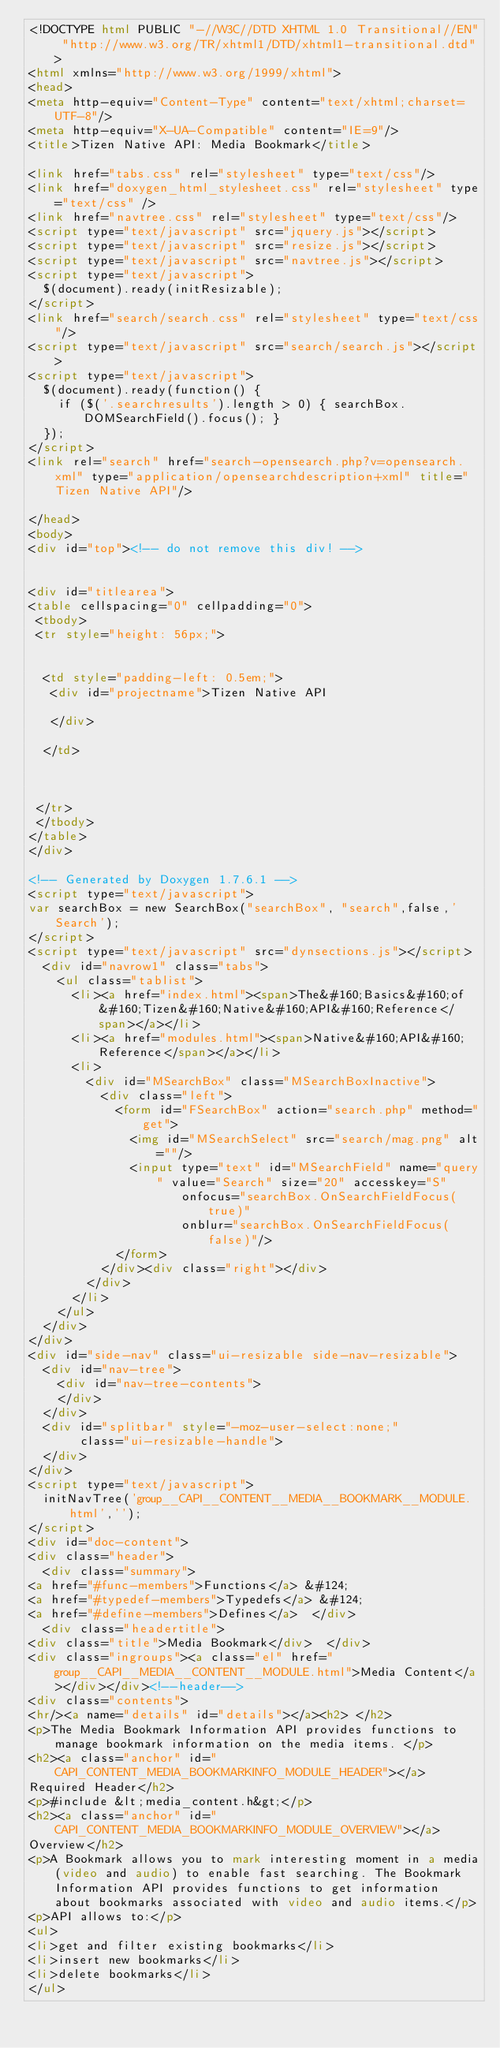Convert code to text. <code><loc_0><loc_0><loc_500><loc_500><_HTML_><!DOCTYPE html PUBLIC "-//W3C//DTD XHTML 1.0 Transitional//EN" "http://www.w3.org/TR/xhtml1/DTD/xhtml1-transitional.dtd">
<html xmlns="http://www.w3.org/1999/xhtml">
<head>
<meta http-equiv="Content-Type" content="text/xhtml;charset=UTF-8"/>
<meta http-equiv="X-UA-Compatible" content="IE=9"/>
<title>Tizen Native API: Media Bookmark</title>

<link href="tabs.css" rel="stylesheet" type="text/css"/>
<link href="doxygen_html_stylesheet.css" rel="stylesheet" type="text/css" />
<link href="navtree.css" rel="stylesheet" type="text/css"/>
<script type="text/javascript" src="jquery.js"></script>
<script type="text/javascript" src="resize.js"></script>
<script type="text/javascript" src="navtree.js"></script>
<script type="text/javascript">
  $(document).ready(initResizable);
</script>
<link href="search/search.css" rel="stylesheet" type="text/css"/>
<script type="text/javascript" src="search/search.js"></script>
<script type="text/javascript">
  $(document).ready(function() {
    if ($('.searchresults').length > 0) { searchBox.DOMSearchField().focus(); }
  });
</script>
<link rel="search" href="search-opensearch.php?v=opensearch.xml" type="application/opensearchdescription+xml" title="Tizen Native API"/>

</head>
<body>
<div id="top"><!-- do not remove this div! -->


<div id="titlearea">
<table cellspacing="0" cellpadding="0">
 <tbody>
 <tr style="height: 56px;">
  
  
  <td style="padding-left: 0.5em;">
   <div id="projectname">Tizen Native API
   
   </div>
   
  </td>
  
  
  
 </tr>
 </tbody>
</table>
</div>

<!-- Generated by Doxygen 1.7.6.1 -->
<script type="text/javascript">
var searchBox = new SearchBox("searchBox", "search",false,'Search');
</script>
<script type="text/javascript" src="dynsections.js"></script>
  <div id="navrow1" class="tabs">
    <ul class="tablist">
      <li><a href="index.html"><span>The&#160;Basics&#160;of&#160;Tizen&#160;Native&#160;API&#160;Reference</span></a></li>
      <li><a href="modules.html"><span>Native&#160;API&#160;Reference</span></a></li>
      <li>
        <div id="MSearchBox" class="MSearchBoxInactive">
          <div class="left">
            <form id="FSearchBox" action="search.php" method="get">
              <img id="MSearchSelect" src="search/mag.png" alt=""/>
              <input type="text" id="MSearchField" name="query" value="Search" size="20" accesskey="S" 
                     onfocus="searchBox.OnSearchFieldFocus(true)" 
                     onblur="searchBox.OnSearchFieldFocus(false)"/>
            </form>
          </div><div class="right"></div>
        </div>
      </li>
    </ul>
  </div>
</div>
<div id="side-nav" class="ui-resizable side-nav-resizable">
  <div id="nav-tree">
    <div id="nav-tree-contents">
    </div>
  </div>
  <div id="splitbar" style="-moz-user-select:none;" 
       class="ui-resizable-handle">
  </div>
</div>
<script type="text/javascript">
  initNavTree('group__CAPI__CONTENT__MEDIA__BOOKMARK__MODULE.html','');
</script>
<div id="doc-content">
<div class="header">
  <div class="summary">
<a href="#func-members">Functions</a> &#124;
<a href="#typedef-members">Typedefs</a> &#124;
<a href="#define-members">Defines</a>  </div>
  <div class="headertitle">
<div class="title">Media Bookmark</div>  </div>
<div class="ingroups"><a class="el" href="group__CAPI__MEDIA__CONTENT__MODULE.html">Media Content</a></div></div><!--header-->
<div class="contents">
<hr/><a name="details" id="details"></a><h2> </h2>
<p>The Media Bookmark Information API provides functions to manage bookmark information on the media items. </p>
<h2><a class="anchor" id="CAPI_CONTENT_MEDIA_BOOKMARKINFO_MODULE_HEADER"></a>
Required Header</h2>
<p>#include &lt;media_content.h&gt;</p>
<h2><a class="anchor" id="CAPI_CONTENT_MEDIA_BOOKMARKINFO_MODULE_OVERVIEW"></a>
Overview</h2>
<p>A Bookmark allows you to mark interesting moment in a media(video and audio) to enable fast searching. The Bookmark Information API provides functions to get information about bookmarks associated with video and audio items.</p>
<p>API allows to:</p>
<ul>
<li>get and filter existing bookmarks</li>
<li>insert new bookmarks</li>
<li>delete bookmarks</li>
</ul></code> 